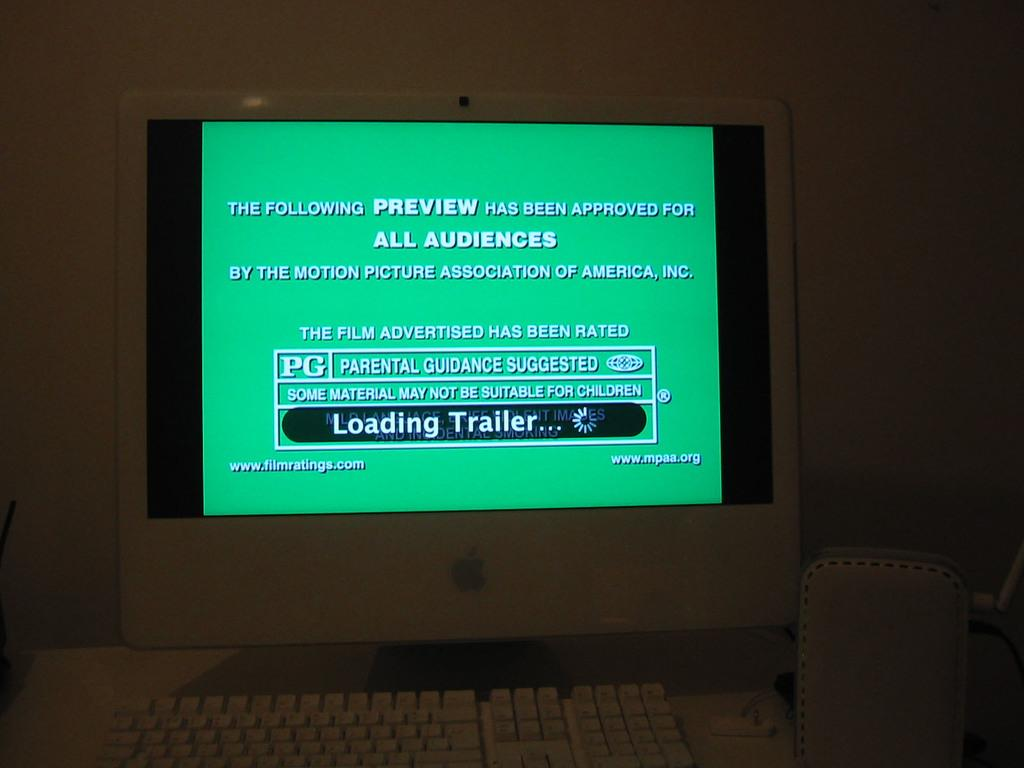<image>
Give a short and clear explanation of the subsequent image. A parental guidance warning is displayed on a TV screen indicating this movie is approved for all audiences. 